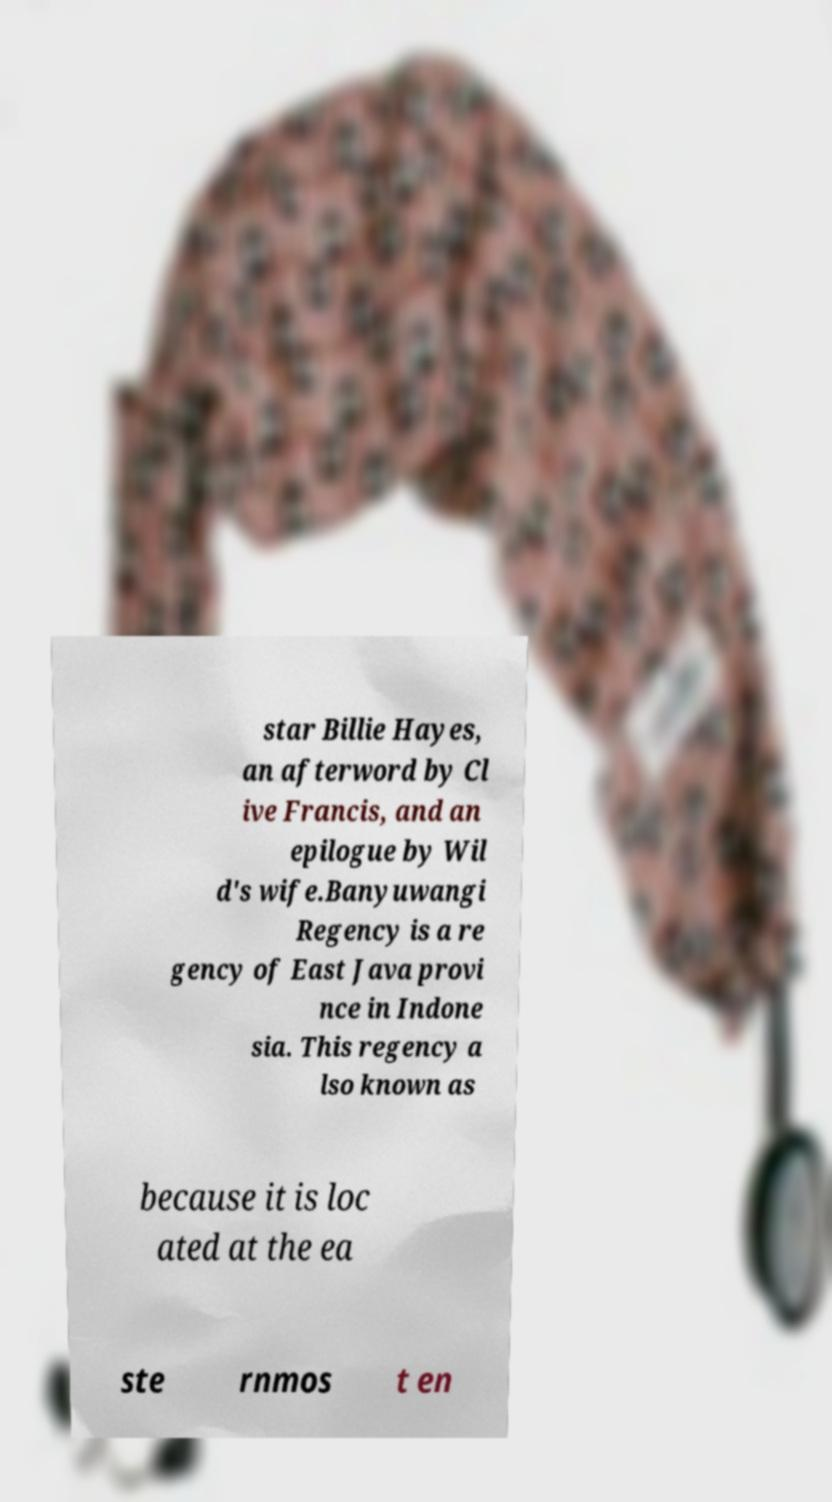What messages or text are displayed in this image? I need them in a readable, typed format. star Billie Hayes, an afterword by Cl ive Francis, and an epilogue by Wil d's wife.Banyuwangi Regency is a re gency of East Java provi nce in Indone sia. This regency a lso known as because it is loc ated at the ea ste rnmos t en 